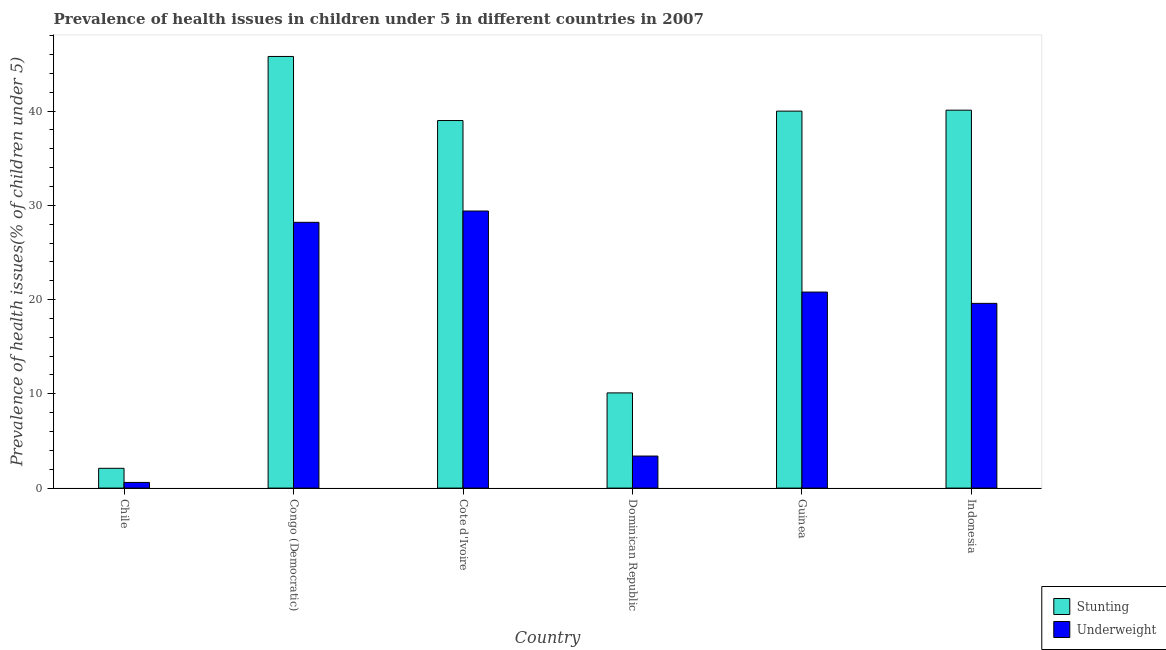How many groups of bars are there?
Offer a very short reply. 6. Are the number of bars per tick equal to the number of legend labels?
Offer a very short reply. Yes. Are the number of bars on each tick of the X-axis equal?
Your answer should be compact. Yes. How many bars are there on the 2nd tick from the left?
Offer a terse response. 2. What is the label of the 4th group of bars from the left?
Provide a short and direct response. Dominican Republic. In how many cases, is the number of bars for a given country not equal to the number of legend labels?
Offer a very short reply. 0. What is the percentage of stunted children in Chile?
Your answer should be compact. 2.1. Across all countries, what is the maximum percentage of stunted children?
Offer a very short reply. 45.8. Across all countries, what is the minimum percentage of stunted children?
Offer a very short reply. 2.1. In which country was the percentage of stunted children maximum?
Keep it short and to the point. Congo (Democratic). What is the total percentage of stunted children in the graph?
Your response must be concise. 177.1. What is the difference between the percentage of underweight children in Congo (Democratic) and that in Indonesia?
Offer a very short reply. 8.6. What is the difference between the percentage of stunted children in Chile and the percentage of underweight children in Cote d'Ivoire?
Keep it short and to the point. -27.3. What is the average percentage of underweight children per country?
Your answer should be very brief. 17. What is the difference between the percentage of underweight children and percentage of stunted children in Cote d'Ivoire?
Give a very brief answer. -9.6. In how many countries, is the percentage of stunted children greater than 6 %?
Offer a terse response. 5. What is the ratio of the percentage of underweight children in Cote d'Ivoire to that in Indonesia?
Your answer should be very brief. 1.5. What is the difference between the highest and the second highest percentage of underweight children?
Ensure brevity in your answer.  1.2. What is the difference between the highest and the lowest percentage of stunted children?
Make the answer very short. 43.7. What does the 2nd bar from the left in Congo (Democratic) represents?
Provide a short and direct response. Underweight. What does the 1st bar from the right in Chile represents?
Your answer should be compact. Underweight. Are all the bars in the graph horizontal?
Your answer should be very brief. No. Does the graph contain any zero values?
Offer a very short reply. No. Does the graph contain grids?
Make the answer very short. No. Where does the legend appear in the graph?
Provide a short and direct response. Bottom right. How are the legend labels stacked?
Offer a terse response. Vertical. What is the title of the graph?
Keep it short and to the point. Prevalence of health issues in children under 5 in different countries in 2007. What is the label or title of the X-axis?
Offer a very short reply. Country. What is the label or title of the Y-axis?
Your answer should be very brief. Prevalence of health issues(% of children under 5). What is the Prevalence of health issues(% of children under 5) of Stunting in Chile?
Make the answer very short. 2.1. What is the Prevalence of health issues(% of children under 5) of Underweight in Chile?
Ensure brevity in your answer.  0.6. What is the Prevalence of health issues(% of children under 5) of Stunting in Congo (Democratic)?
Your answer should be very brief. 45.8. What is the Prevalence of health issues(% of children under 5) of Underweight in Congo (Democratic)?
Your answer should be compact. 28.2. What is the Prevalence of health issues(% of children under 5) in Stunting in Cote d'Ivoire?
Ensure brevity in your answer.  39. What is the Prevalence of health issues(% of children under 5) of Underweight in Cote d'Ivoire?
Make the answer very short. 29.4. What is the Prevalence of health issues(% of children under 5) in Stunting in Dominican Republic?
Ensure brevity in your answer.  10.1. What is the Prevalence of health issues(% of children under 5) of Underweight in Dominican Republic?
Your answer should be very brief. 3.4. What is the Prevalence of health issues(% of children under 5) in Stunting in Guinea?
Your answer should be compact. 40. What is the Prevalence of health issues(% of children under 5) in Underweight in Guinea?
Provide a succinct answer. 20.8. What is the Prevalence of health issues(% of children under 5) of Stunting in Indonesia?
Give a very brief answer. 40.1. What is the Prevalence of health issues(% of children under 5) of Underweight in Indonesia?
Keep it short and to the point. 19.6. Across all countries, what is the maximum Prevalence of health issues(% of children under 5) in Stunting?
Offer a terse response. 45.8. Across all countries, what is the maximum Prevalence of health issues(% of children under 5) of Underweight?
Make the answer very short. 29.4. Across all countries, what is the minimum Prevalence of health issues(% of children under 5) in Stunting?
Make the answer very short. 2.1. Across all countries, what is the minimum Prevalence of health issues(% of children under 5) of Underweight?
Your answer should be very brief. 0.6. What is the total Prevalence of health issues(% of children under 5) in Stunting in the graph?
Give a very brief answer. 177.1. What is the total Prevalence of health issues(% of children under 5) in Underweight in the graph?
Offer a terse response. 102. What is the difference between the Prevalence of health issues(% of children under 5) in Stunting in Chile and that in Congo (Democratic)?
Offer a very short reply. -43.7. What is the difference between the Prevalence of health issues(% of children under 5) of Underweight in Chile and that in Congo (Democratic)?
Keep it short and to the point. -27.6. What is the difference between the Prevalence of health issues(% of children under 5) in Stunting in Chile and that in Cote d'Ivoire?
Provide a succinct answer. -36.9. What is the difference between the Prevalence of health issues(% of children under 5) in Underweight in Chile and that in Cote d'Ivoire?
Provide a short and direct response. -28.8. What is the difference between the Prevalence of health issues(% of children under 5) of Stunting in Chile and that in Guinea?
Ensure brevity in your answer.  -37.9. What is the difference between the Prevalence of health issues(% of children under 5) of Underweight in Chile and that in Guinea?
Provide a short and direct response. -20.2. What is the difference between the Prevalence of health issues(% of children under 5) of Stunting in Chile and that in Indonesia?
Give a very brief answer. -38. What is the difference between the Prevalence of health issues(% of children under 5) in Stunting in Congo (Democratic) and that in Dominican Republic?
Your response must be concise. 35.7. What is the difference between the Prevalence of health issues(% of children under 5) of Underweight in Congo (Democratic) and that in Dominican Republic?
Keep it short and to the point. 24.8. What is the difference between the Prevalence of health issues(% of children under 5) of Stunting in Congo (Democratic) and that in Indonesia?
Make the answer very short. 5.7. What is the difference between the Prevalence of health issues(% of children under 5) in Underweight in Congo (Democratic) and that in Indonesia?
Offer a terse response. 8.6. What is the difference between the Prevalence of health issues(% of children under 5) in Stunting in Cote d'Ivoire and that in Dominican Republic?
Ensure brevity in your answer.  28.9. What is the difference between the Prevalence of health issues(% of children under 5) of Underweight in Cote d'Ivoire and that in Dominican Republic?
Your response must be concise. 26. What is the difference between the Prevalence of health issues(% of children under 5) in Stunting in Cote d'Ivoire and that in Guinea?
Keep it short and to the point. -1. What is the difference between the Prevalence of health issues(% of children under 5) of Stunting in Dominican Republic and that in Guinea?
Your response must be concise. -29.9. What is the difference between the Prevalence of health issues(% of children under 5) in Underweight in Dominican Republic and that in Guinea?
Provide a succinct answer. -17.4. What is the difference between the Prevalence of health issues(% of children under 5) in Underweight in Dominican Republic and that in Indonesia?
Your response must be concise. -16.2. What is the difference between the Prevalence of health issues(% of children under 5) of Stunting in Guinea and that in Indonesia?
Give a very brief answer. -0.1. What is the difference between the Prevalence of health issues(% of children under 5) of Stunting in Chile and the Prevalence of health issues(% of children under 5) of Underweight in Congo (Democratic)?
Give a very brief answer. -26.1. What is the difference between the Prevalence of health issues(% of children under 5) of Stunting in Chile and the Prevalence of health issues(% of children under 5) of Underweight in Cote d'Ivoire?
Your response must be concise. -27.3. What is the difference between the Prevalence of health issues(% of children under 5) of Stunting in Chile and the Prevalence of health issues(% of children under 5) of Underweight in Dominican Republic?
Your answer should be compact. -1.3. What is the difference between the Prevalence of health issues(% of children under 5) of Stunting in Chile and the Prevalence of health issues(% of children under 5) of Underweight in Guinea?
Your response must be concise. -18.7. What is the difference between the Prevalence of health issues(% of children under 5) in Stunting in Chile and the Prevalence of health issues(% of children under 5) in Underweight in Indonesia?
Provide a succinct answer. -17.5. What is the difference between the Prevalence of health issues(% of children under 5) in Stunting in Congo (Democratic) and the Prevalence of health issues(% of children under 5) in Underweight in Cote d'Ivoire?
Provide a short and direct response. 16.4. What is the difference between the Prevalence of health issues(% of children under 5) of Stunting in Congo (Democratic) and the Prevalence of health issues(% of children under 5) of Underweight in Dominican Republic?
Your answer should be very brief. 42.4. What is the difference between the Prevalence of health issues(% of children under 5) in Stunting in Congo (Democratic) and the Prevalence of health issues(% of children under 5) in Underweight in Indonesia?
Offer a terse response. 26.2. What is the difference between the Prevalence of health issues(% of children under 5) of Stunting in Cote d'Ivoire and the Prevalence of health issues(% of children under 5) of Underweight in Dominican Republic?
Your answer should be very brief. 35.6. What is the difference between the Prevalence of health issues(% of children under 5) of Stunting in Cote d'Ivoire and the Prevalence of health issues(% of children under 5) of Underweight in Guinea?
Ensure brevity in your answer.  18.2. What is the difference between the Prevalence of health issues(% of children under 5) in Stunting in Dominican Republic and the Prevalence of health issues(% of children under 5) in Underweight in Guinea?
Your response must be concise. -10.7. What is the difference between the Prevalence of health issues(% of children under 5) of Stunting in Guinea and the Prevalence of health issues(% of children under 5) of Underweight in Indonesia?
Offer a terse response. 20.4. What is the average Prevalence of health issues(% of children under 5) in Stunting per country?
Ensure brevity in your answer.  29.52. What is the difference between the Prevalence of health issues(% of children under 5) in Stunting and Prevalence of health issues(% of children under 5) in Underweight in Chile?
Ensure brevity in your answer.  1.5. What is the difference between the Prevalence of health issues(% of children under 5) of Stunting and Prevalence of health issues(% of children under 5) of Underweight in Congo (Democratic)?
Your response must be concise. 17.6. What is the difference between the Prevalence of health issues(% of children under 5) of Stunting and Prevalence of health issues(% of children under 5) of Underweight in Guinea?
Ensure brevity in your answer.  19.2. What is the difference between the Prevalence of health issues(% of children under 5) in Stunting and Prevalence of health issues(% of children under 5) in Underweight in Indonesia?
Provide a short and direct response. 20.5. What is the ratio of the Prevalence of health issues(% of children under 5) in Stunting in Chile to that in Congo (Democratic)?
Offer a terse response. 0.05. What is the ratio of the Prevalence of health issues(% of children under 5) of Underweight in Chile to that in Congo (Democratic)?
Offer a very short reply. 0.02. What is the ratio of the Prevalence of health issues(% of children under 5) of Stunting in Chile to that in Cote d'Ivoire?
Your answer should be compact. 0.05. What is the ratio of the Prevalence of health issues(% of children under 5) of Underweight in Chile to that in Cote d'Ivoire?
Offer a terse response. 0.02. What is the ratio of the Prevalence of health issues(% of children under 5) of Stunting in Chile to that in Dominican Republic?
Keep it short and to the point. 0.21. What is the ratio of the Prevalence of health issues(% of children under 5) in Underweight in Chile to that in Dominican Republic?
Keep it short and to the point. 0.18. What is the ratio of the Prevalence of health issues(% of children under 5) in Stunting in Chile to that in Guinea?
Offer a terse response. 0.05. What is the ratio of the Prevalence of health issues(% of children under 5) in Underweight in Chile to that in Guinea?
Your answer should be very brief. 0.03. What is the ratio of the Prevalence of health issues(% of children under 5) of Stunting in Chile to that in Indonesia?
Ensure brevity in your answer.  0.05. What is the ratio of the Prevalence of health issues(% of children under 5) of Underweight in Chile to that in Indonesia?
Provide a short and direct response. 0.03. What is the ratio of the Prevalence of health issues(% of children under 5) of Stunting in Congo (Democratic) to that in Cote d'Ivoire?
Keep it short and to the point. 1.17. What is the ratio of the Prevalence of health issues(% of children under 5) of Underweight in Congo (Democratic) to that in Cote d'Ivoire?
Provide a succinct answer. 0.96. What is the ratio of the Prevalence of health issues(% of children under 5) of Stunting in Congo (Democratic) to that in Dominican Republic?
Make the answer very short. 4.53. What is the ratio of the Prevalence of health issues(% of children under 5) in Underweight in Congo (Democratic) to that in Dominican Republic?
Offer a terse response. 8.29. What is the ratio of the Prevalence of health issues(% of children under 5) of Stunting in Congo (Democratic) to that in Guinea?
Offer a very short reply. 1.15. What is the ratio of the Prevalence of health issues(% of children under 5) in Underweight in Congo (Democratic) to that in Guinea?
Offer a terse response. 1.36. What is the ratio of the Prevalence of health issues(% of children under 5) of Stunting in Congo (Democratic) to that in Indonesia?
Provide a succinct answer. 1.14. What is the ratio of the Prevalence of health issues(% of children under 5) of Underweight in Congo (Democratic) to that in Indonesia?
Provide a succinct answer. 1.44. What is the ratio of the Prevalence of health issues(% of children under 5) of Stunting in Cote d'Ivoire to that in Dominican Republic?
Offer a terse response. 3.86. What is the ratio of the Prevalence of health issues(% of children under 5) in Underweight in Cote d'Ivoire to that in Dominican Republic?
Give a very brief answer. 8.65. What is the ratio of the Prevalence of health issues(% of children under 5) in Stunting in Cote d'Ivoire to that in Guinea?
Make the answer very short. 0.97. What is the ratio of the Prevalence of health issues(% of children under 5) of Underweight in Cote d'Ivoire to that in Guinea?
Offer a very short reply. 1.41. What is the ratio of the Prevalence of health issues(% of children under 5) of Stunting in Cote d'Ivoire to that in Indonesia?
Provide a short and direct response. 0.97. What is the ratio of the Prevalence of health issues(% of children under 5) of Stunting in Dominican Republic to that in Guinea?
Your answer should be very brief. 0.25. What is the ratio of the Prevalence of health issues(% of children under 5) in Underweight in Dominican Republic to that in Guinea?
Keep it short and to the point. 0.16. What is the ratio of the Prevalence of health issues(% of children under 5) in Stunting in Dominican Republic to that in Indonesia?
Provide a short and direct response. 0.25. What is the ratio of the Prevalence of health issues(% of children under 5) of Underweight in Dominican Republic to that in Indonesia?
Offer a terse response. 0.17. What is the ratio of the Prevalence of health issues(% of children under 5) of Stunting in Guinea to that in Indonesia?
Your answer should be compact. 1. What is the ratio of the Prevalence of health issues(% of children under 5) in Underweight in Guinea to that in Indonesia?
Your answer should be compact. 1.06. What is the difference between the highest and the second highest Prevalence of health issues(% of children under 5) in Stunting?
Your answer should be compact. 5.7. What is the difference between the highest and the lowest Prevalence of health issues(% of children under 5) of Stunting?
Offer a terse response. 43.7. What is the difference between the highest and the lowest Prevalence of health issues(% of children under 5) of Underweight?
Provide a short and direct response. 28.8. 